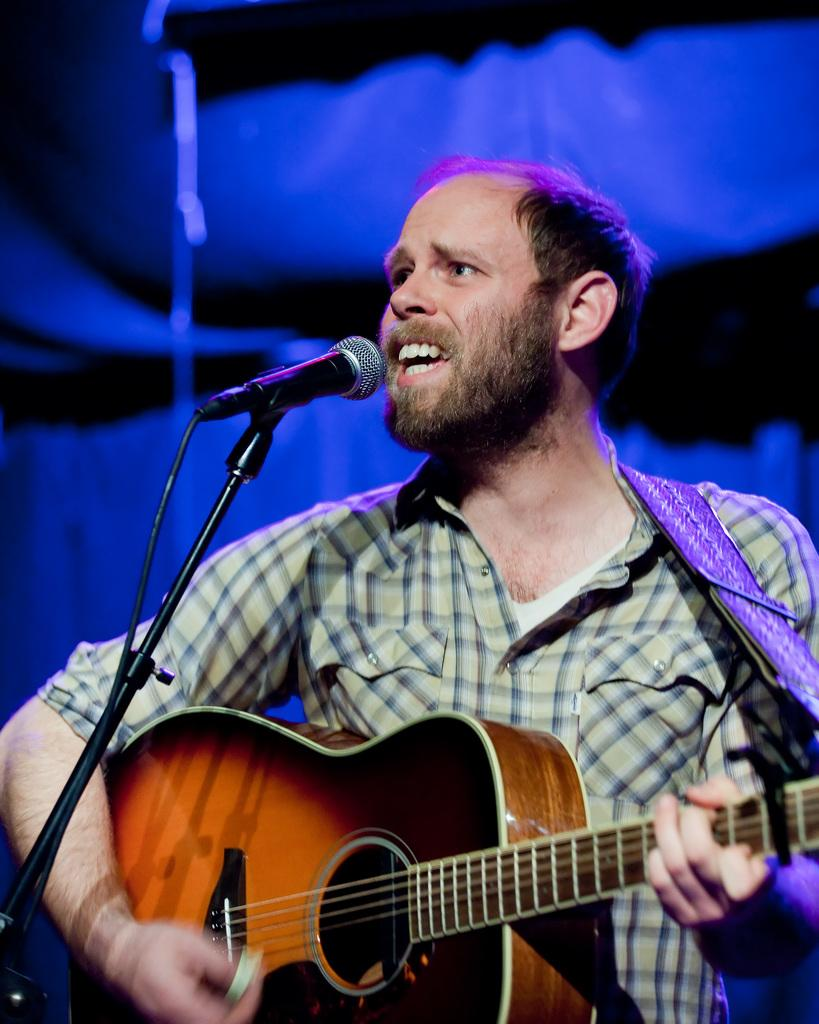What is the main subject of the image? There is a guy in the image. What is the guy holding in the image? The guy is holding a guitar. What is the guy doing with the guitar? The guy is playing the guitar. What other object is present in the image? There is a microphone in the image. What color is the pig in the image? There is no pig present in the image. How does the guy's hair look in the image? The provided facts do not mention the guy's hair, so we cannot answer this question definitively. 